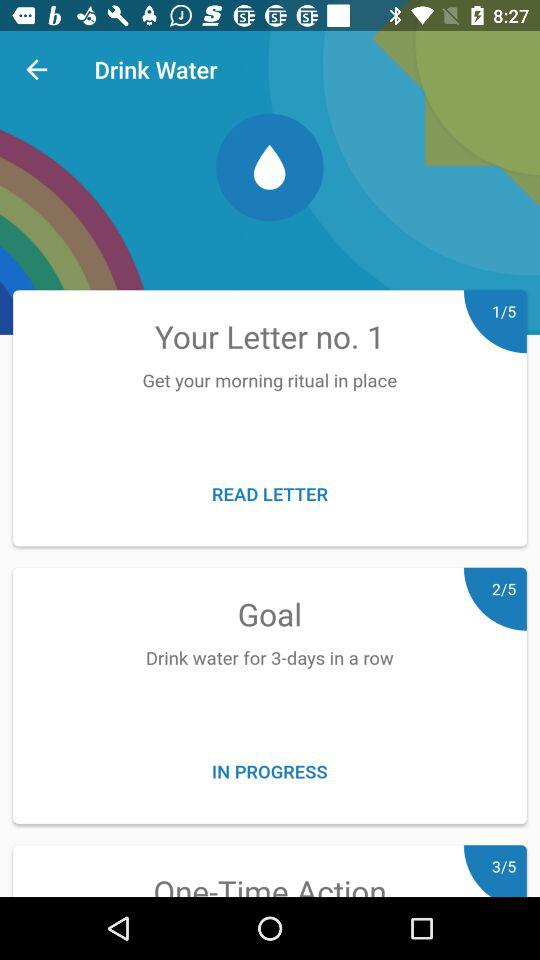For how many days do you have to drink water in a row? You have to drink water for 3 days in a row. 